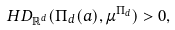Convert formula to latex. <formula><loc_0><loc_0><loc_500><loc_500>H D _ { \mathbb { R } ^ { d } } ( \Pi _ { d } ( a ) , \mu ^ { \Pi _ { d } } ) > 0 ,</formula> 